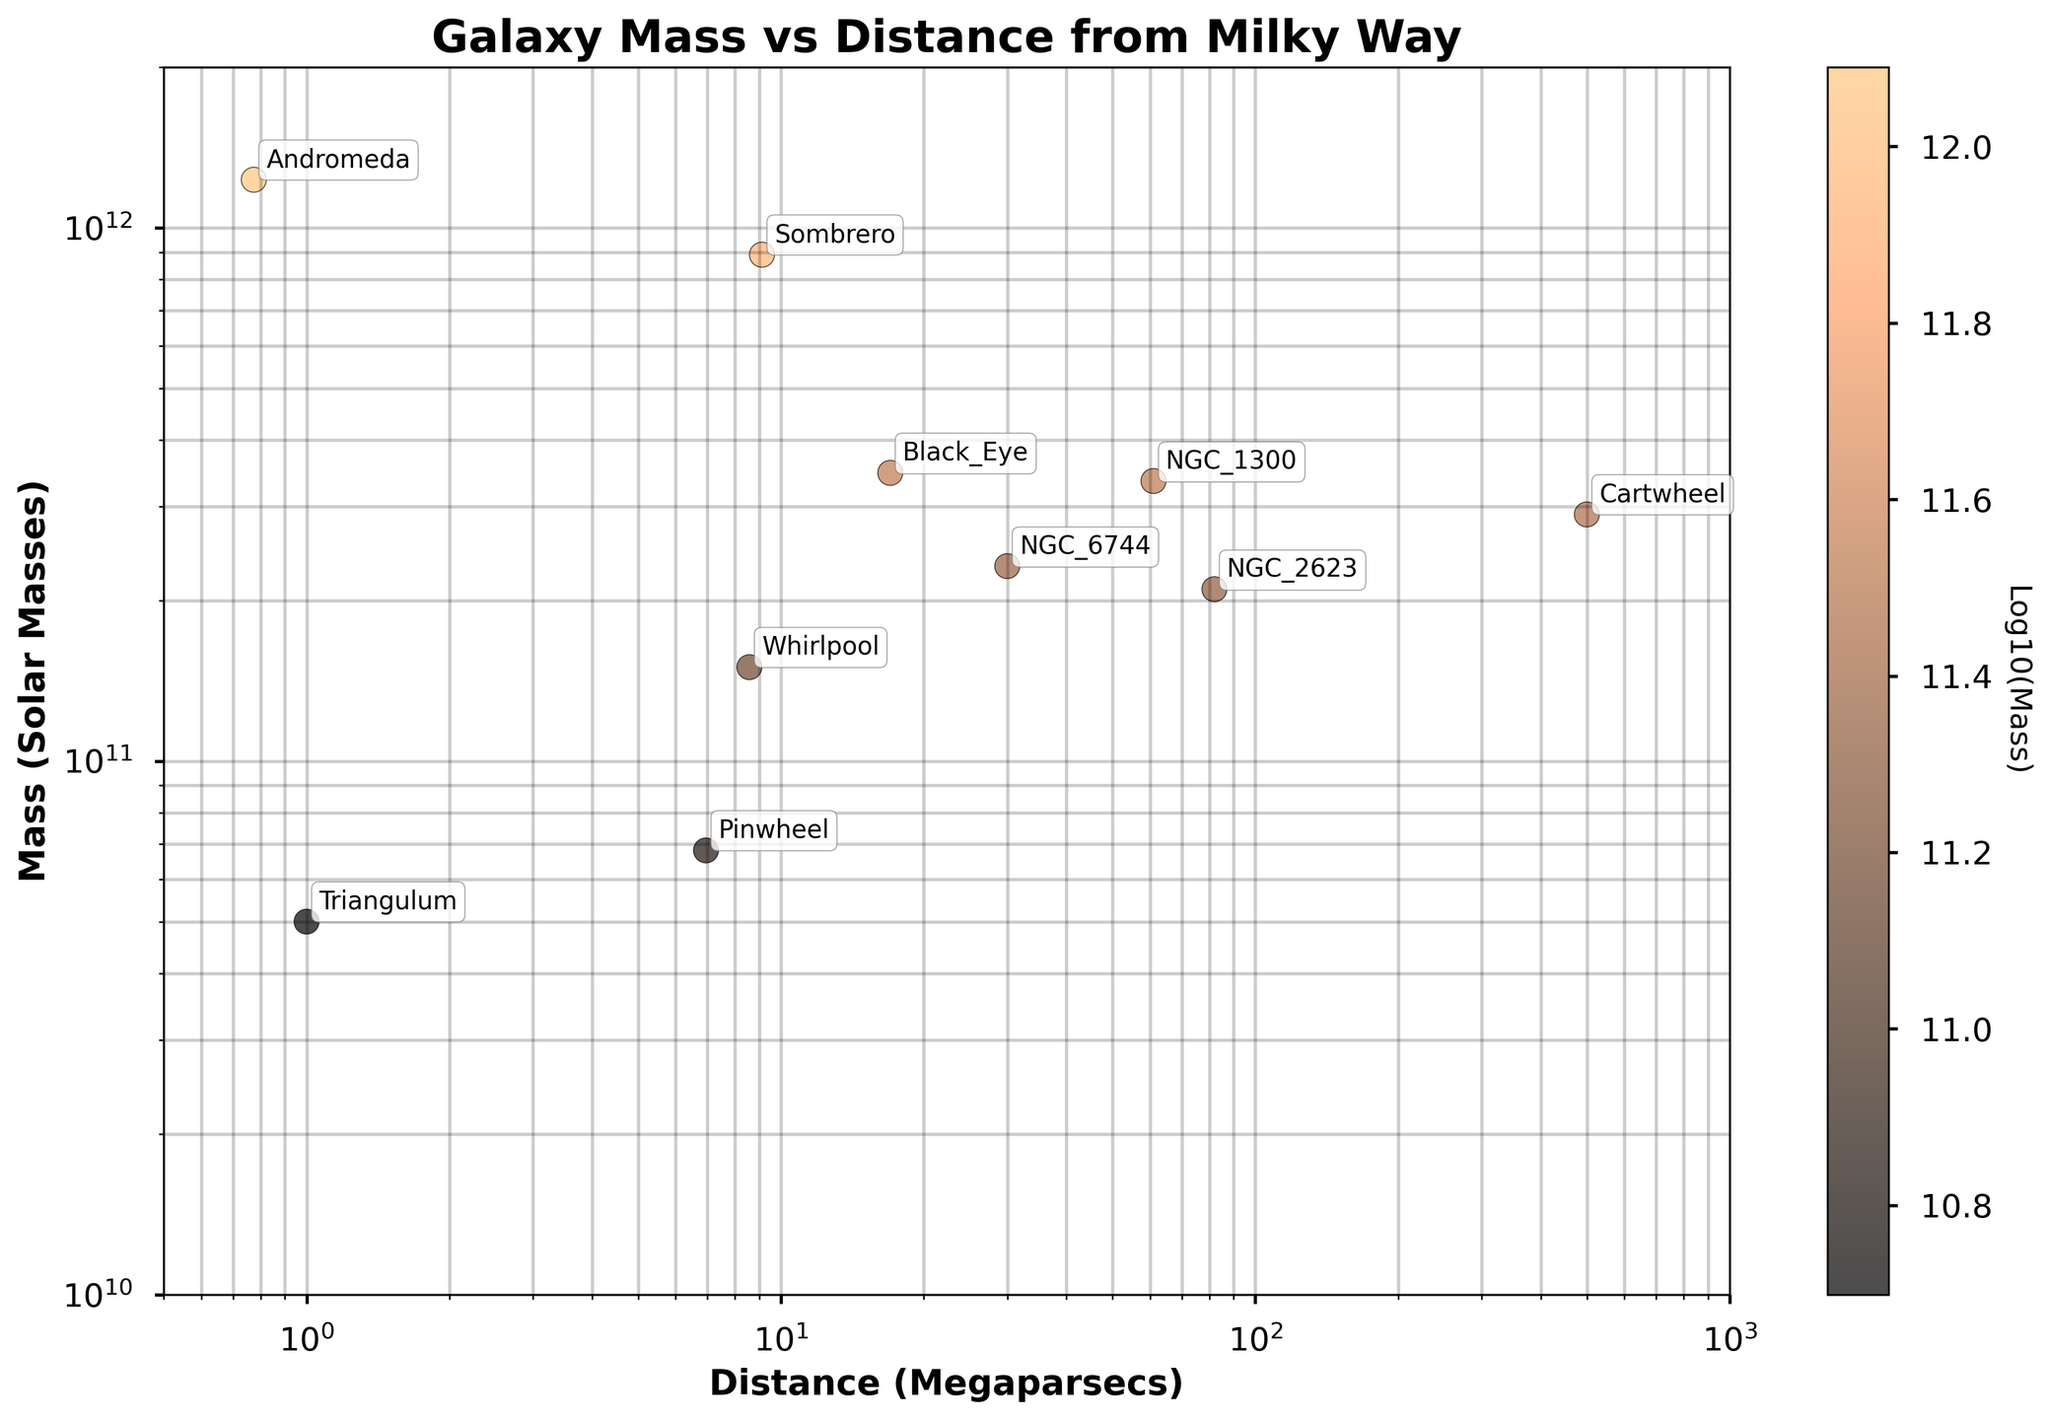Which galaxy is represented by the data point with the lowest mass? The lowest point on the y-axis of the plot (after accounting for the log scale) represents the galaxy with the lowest mass. This point is for the Triangulum galaxy, which has a mass of \(5.0 \times 10^{10}\) solar masses.
Answer: Triangulum What is the galaxy with the longest distance from the Milky Way? To find the galaxy farthest away, we look at the rightmost point on the x-axis (distance in megaparsecs). The galaxy at the farthest point is Cartwheel with a distance of 500 Megaparsecs from the Milky Way.
Answer: Cartwheel Which two galaxies have the closest distance to the Milky Way, and what are their distances? To find the closest galaxies, we look for the points nearest to the left side of the x-axis. These galaxies are Andromeda and Triangulum. Andromeda is at 0.774 map and Triangulum is at 1.000 Mpc from the Milky Way.
Answer: Andromeda (0.774), Triangulum (1.000) Which galaxy has the highest mass, and what is that mass? The topmost point on the y-axis of the log scale plot represents the galaxy with the highest mass. This point is for Andromeda, which has a mass of \(1.23 \times 10^{12}\) solar masses.
Answer: Andromeda, \(1.23 \times 10^{12}\) solar masses What is the approximate mass range for the galaxies on the plot? The y-axis in the log scale ranges from \(1 \times 10^{10}\) to \(2 \times 10^{12}\) solar masses. So, the mass range is approximately from \(1 \times 10^{10}\) to \(2 \times 10^{12}\) solar masses.
Answer: \(1 \times 10^{10}\) to \(2 \times 10^{12}\) solar masses On average, are the closer galaxies more massive or less massive than the farther galaxies? We need to examine the y-values corresponding to the lower x-values (closer galaxies) and compare them with those of the higher x-values (farther galaxies). The closer galaxies like Andromeda (1.23E+12), Triangulum (5.00E+10) have differing masses, whereas the farther galaxies like Cartwheel (2.90E+11), NGC 1300 (3.35E+11) have more consistent masses that fall within the middle range. No clear trend shows a systematic difference in mass based on distance.
Answer: Mass varies without a clear trend Which galaxy is the second farthest from the Milky Way, and what is its distance in megaparsecs? The point second farthest to the right on the x-axis after Cartwheel's point is NGC 1300 at 61 Megaparsecs.
Answer: NGC 1300, 61 Mpc How does the mass of the Sombrero galaxy compare to the mass of the Whirlpool galaxy? Sombrero has a mass of \(8.90 \times 10^{11}\) solar masses and the Whirlpool galaxy has a mass of \(1.50 \times 10^{11}\) solar masses. So, the Sombrero galaxy is more massive.
Answer: Sombrero is more massive 